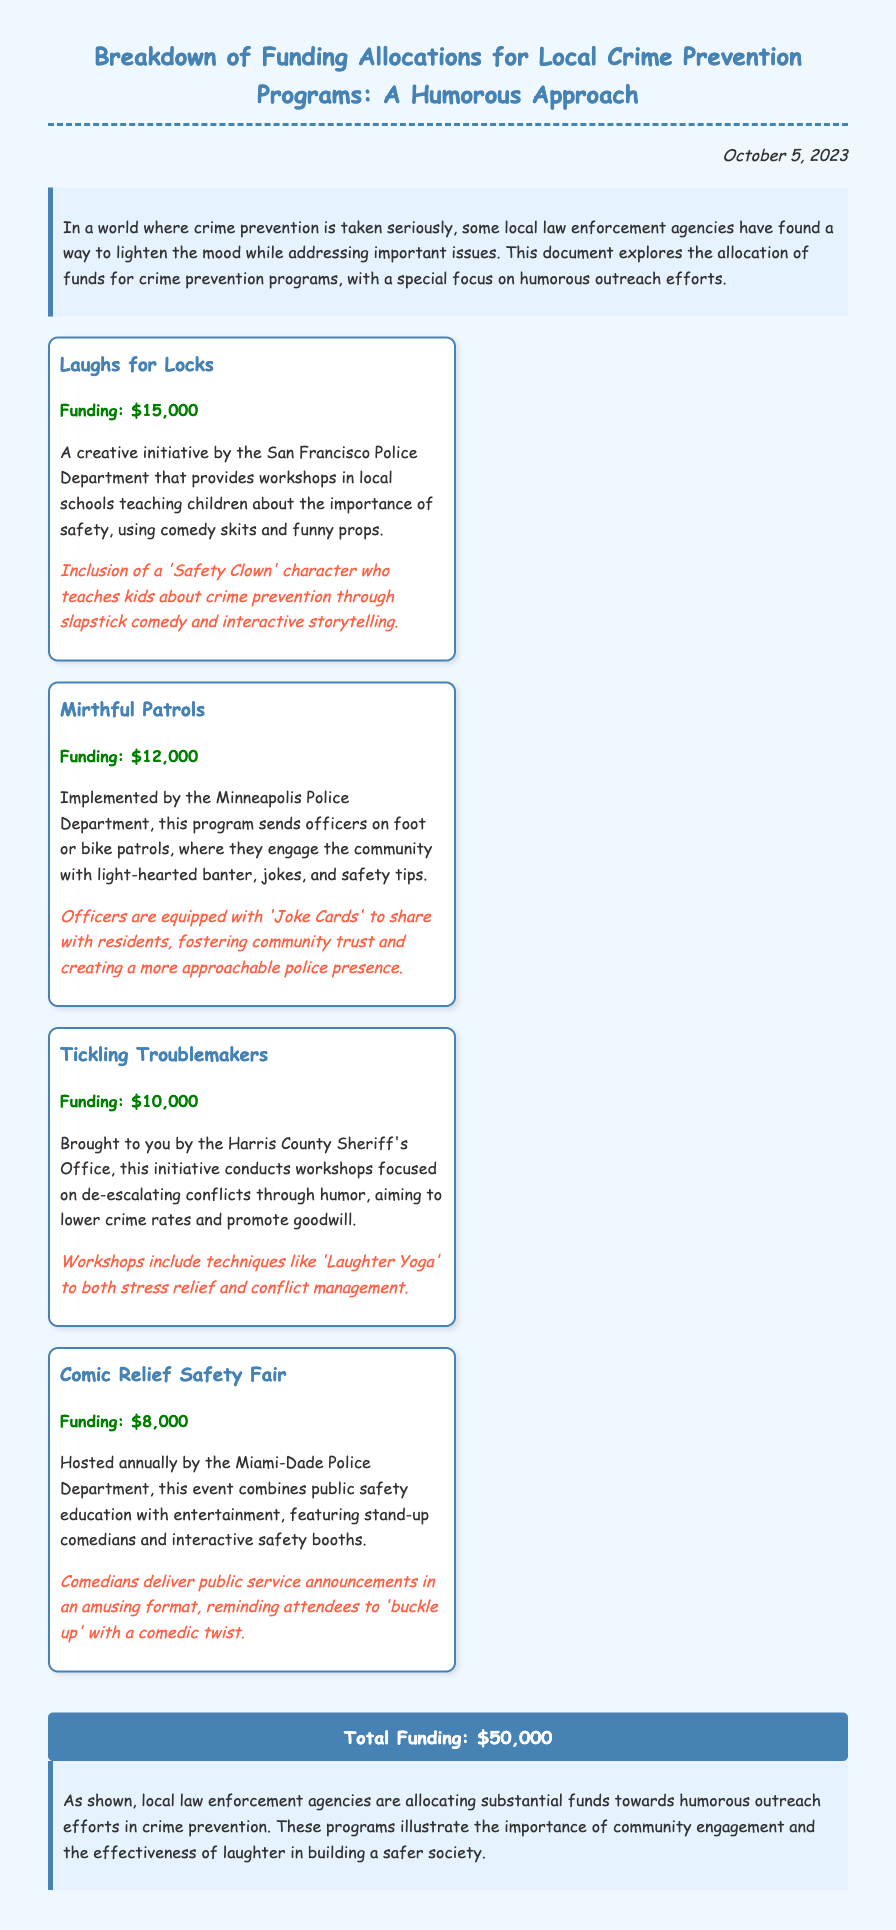what is the title of the document? The title of the document is presented prominently at the top, summarizing its content about funding allocations.
Answer: Breakdown of Funding Allocations for Local Crime Prevention Programs: A Humorous Approach when was the document published? The publication date is stated at the top right corner of the document.
Answer: October 5, 2023 how much funding was allocated to the 'Laughs for Locks' program? The funding amount for this program is mentioned specifically in its section.
Answer: $15,000 which police department implemented the 'Mirthful Patrols' program? This information is provided in the description of the respective program.
Answer: Minneapolis Police Department what is the total funding allocated for all programs mentioned? The document summarizes the total funding at the bottom.
Answer: $50,000 how much funding was allocated to the 'Comic Relief Safety Fair'? The funding amount for this specific program is directly noted in the relevant section.
Answer: $8,000 what humorous technique does the 'Tickling Troublemakers' program focus on? The specific humorous technique is indicated in the program's description.
Answer: Laughter Yoga which character is included in the 'Laughs for Locks' initiative? The document indicates a specific character creation to support the outreach effort.
Answer: Safety Clown what type of cards do officers carry in the 'Mirthful Patrols' program? The document describes a unique feature related to the patrols.
Answer: Joke Cards 